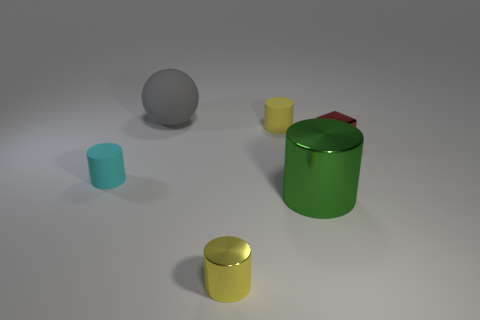Subtract all big green shiny cylinders. How many cylinders are left? 3 Subtract all green cylinders. How many cylinders are left? 3 Subtract all purple spheres. How many yellow cylinders are left? 2 Add 1 small brown things. How many objects exist? 7 Subtract 1 cylinders. How many cylinders are left? 3 Subtract all balls. How many objects are left? 5 Add 6 tiny red blocks. How many tiny red blocks are left? 7 Add 5 gray metallic blocks. How many gray metallic blocks exist? 5 Subtract 1 gray balls. How many objects are left? 5 Subtract all red cylinders. Subtract all blue blocks. How many cylinders are left? 4 